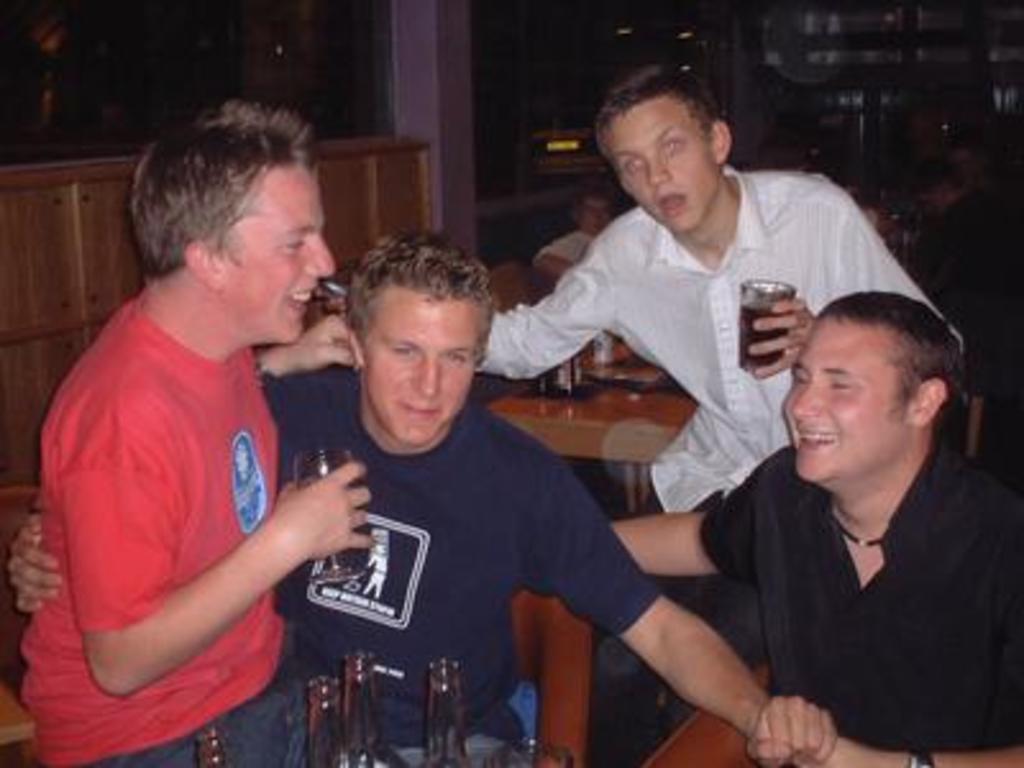How would you summarize this image in a sentence or two? In this image, we can see people sitting and smiling some are holding glasses, which are containing drink. At the bottom, there are some bottles and in the background, there are tables and we can see some objects on them and there is a cup board and a wall and some other objects. 